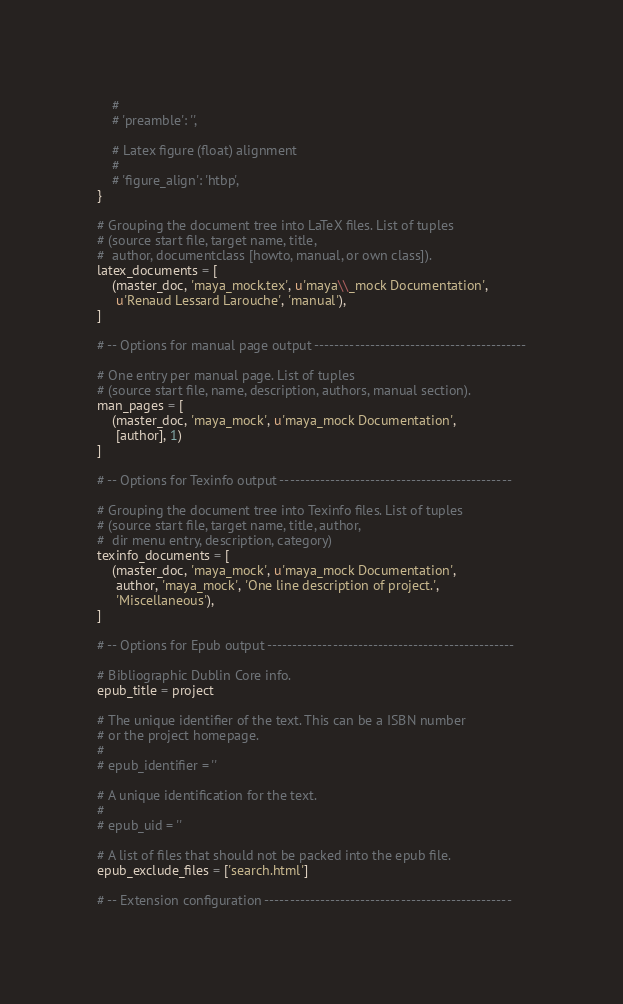<code> <loc_0><loc_0><loc_500><loc_500><_Python_>    #
    # 'preamble': '',

    # Latex figure (float) alignment
    #
    # 'figure_align': 'htbp',
}

# Grouping the document tree into LaTeX files. List of tuples
# (source start file, target name, title,
#  author, documentclass [howto, manual, or own class]).
latex_documents = [
    (master_doc, 'maya_mock.tex', u'maya\\_mock Documentation',
     u'Renaud Lessard Larouche', 'manual'),
]

# -- Options for manual page output ------------------------------------------

# One entry per manual page. List of tuples
# (source start file, name, description, authors, manual section).
man_pages = [
    (master_doc, 'maya_mock', u'maya_mock Documentation',
     [author], 1)
]

# -- Options for Texinfo output ----------------------------------------------

# Grouping the document tree into Texinfo files. List of tuples
# (source start file, target name, title, author,
#  dir menu entry, description, category)
texinfo_documents = [
    (master_doc, 'maya_mock', u'maya_mock Documentation',
     author, 'maya_mock', 'One line description of project.',
     'Miscellaneous'),
]

# -- Options for Epub output -------------------------------------------------

# Bibliographic Dublin Core info.
epub_title = project

# The unique identifier of the text. This can be a ISBN number
# or the project homepage.
#
# epub_identifier = ''

# A unique identification for the text.
#
# epub_uid = ''

# A list of files that should not be packed into the epub file.
epub_exclude_files = ['search.html']

# -- Extension configuration -------------------------------------------------
</code> 